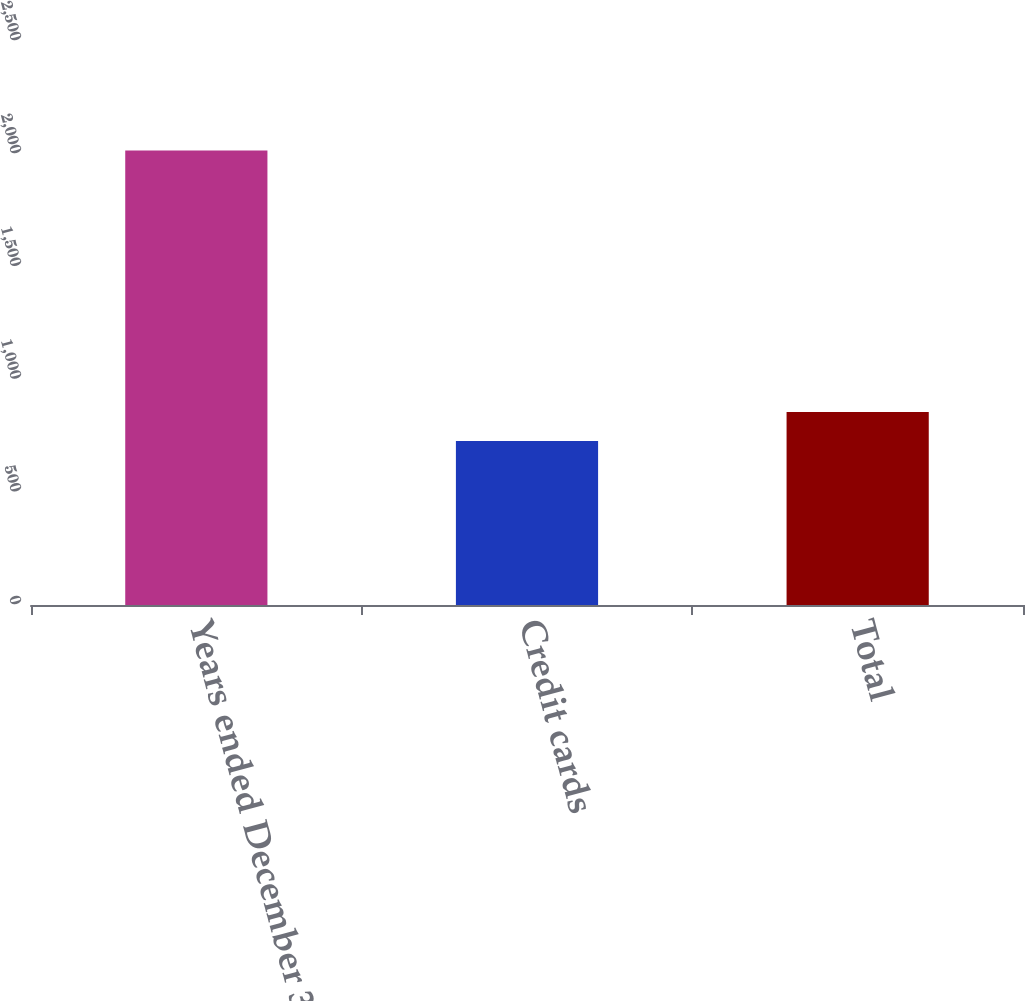Convert chart. <chart><loc_0><loc_0><loc_500><loc_500><bar_chart><fcel>Years ended December 31<fcel>Credit cards<fcel>Total<nl><fcel>2015<fcel>727<fcel>855.8<nl></chart> 